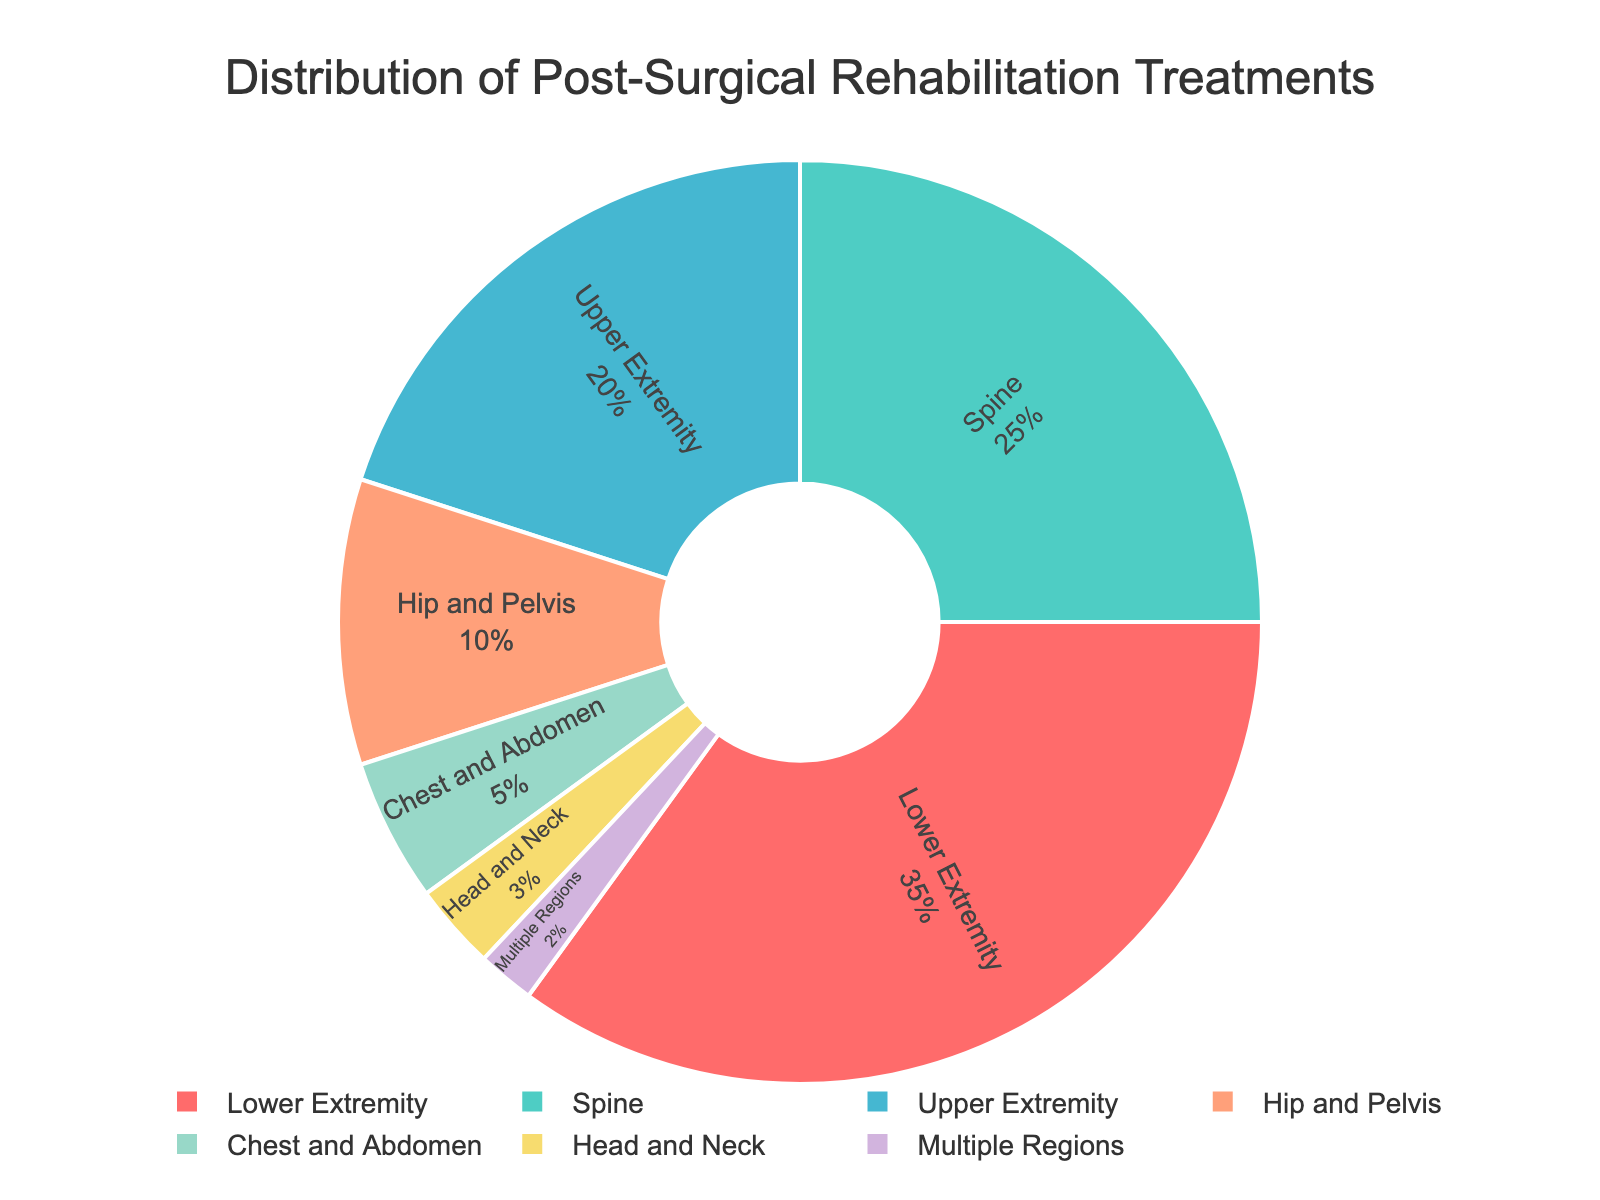What is the largest percentage for a single body region? By inspecting the pie chart, the largest segment corresponds to the "Lower Extremity" region, which has a percentage label of 35%.
Answer: 35% What is the combined percentage for Spine and Upper Extremity treatments? To find the combined percentage for Spine and Upper Extremity, add the percentages: Spine (25%) + Upper Extremity (20%) = 45%.
Answer: 45% Which body region has the smallest percentage of post-surgical rehabilitation treatments? By looking at the pie chart, the smallest segment corresponds to "Multiple Regions" with a label of 2%.
Answer: Multiple Regions How much larger is the percentage of Lower Extremity treatments compared to Hip and Pelvis treatments? Subtract the percentage of Hip and Pelvis (10%) from the percentage of Lower Extremity (35%): 35% - 10% = 25%.
Answer: 25% Are the percentages of Spine and Chest and Abdomen treatments together greater than the percentage for Lower Extremity treatments alone? Add the percentages of Spine (25%) and Chest and Abdomen (5%) to get a combined total of 30%. Then compare it to Lower Extremity's 35%. 30% is less than 35%.
Answer: No What is the difference between the percentages of Upper Extremity and Head and Neck treatments? Subtract the percentage of Head and Neck (3%) from the percentage of Upper Extremity (20%): 20% - 3% = 17%.
Answer: 17% How many body regions have a treatment percentage of 10% or greater? By checking each segment of the pie chart: Lower Extremity (35%), Spine (25%), Upper Extremity (20%), and Hip and Pelvis (10%) are all 10% or greater. This totals to 4 regions.
Answer: 4 Which body region has a yellow segment in the pie chart? By examining the colors in the pie chart, the yellow segment corresponds to the "Chest and Abdomen" region.
Answer: Chest and Abdomen What is the total percentage for body regions not involving the spine? Exclude the Spine (25%) and sum the remaining percentages: Lower Extremity (35%) + Upper Extremity (20%) + Hip and Pelvis (10%) + Chest and Abdomen (5%) + Head and Neck (3%) + Multiple Regions (2%) = 75%.
Answer: 75% Is the "Lower Extremity" segment more than twice as large as the "Head and Neck" segment? Compare the percentages: Lower Extremity (35%) and Head and Neck (3%). Calculate twice the percentage of Head and Neck: 3% * 2 = 6%. 35% is greater than 6%.
Answer: Yes 